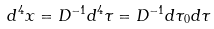<formula> <loc_0><loc_0><loc_500><loc_500>d ^ { 4 } x = D ^ { - 1 } d ^ { 4 } \tau = D ^ { - 1 } d \tau _ { 0 } d \tau</formula> 